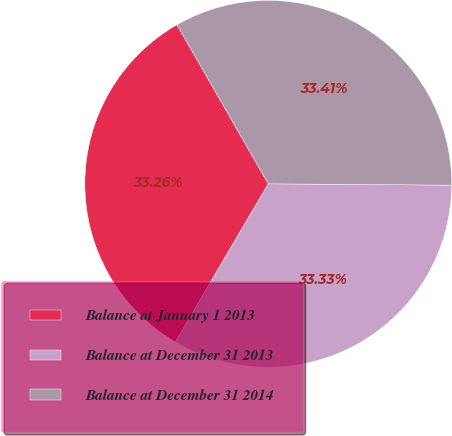<chart> <loc_0><loc_0><loc_500><loc_500><pie_chart><fcel>Balance at January 1 2013<fcel>Balance at December 31 2013<fcel>Balance at December 31 2014<nl><fcel>33.26%<fcel>33.33%<fcel>33.41%<nl></chart> 